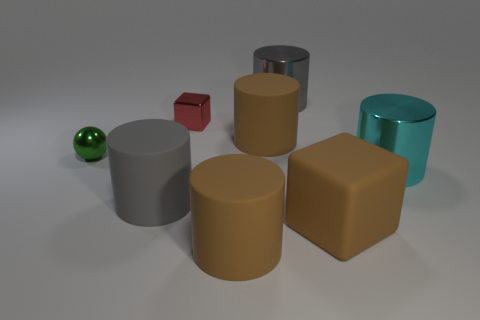What shape is the red thing that is the same material as the tiny green thing?
Your response must be concise. Cube. What number of rubber objects are big brown things or cyan objects?
Offer a very short reply. 3. There is a large shiny cylinder that is behind the big brown thing behind the large gray rubber cylinder; what number of large gray shiny cylinders are right of it?
Your response must be concise. 0. Do the matte thing to the left of the tiny red metallic object and the brown matte cylinder that is in front of the big block have the same size?
Ensure brevity in your answer.  Yes. What material is the other gray thing that is the same shape as the big gray shiny object?
Offer a terse response. Rubber. How many small things are either green spheres or gray things?
Offer a terse response. 1. What is the tiny green ball made of?
Provide a short and direct response. Metal. There is a cylinder that is to the right of the gray matte cylinder and in front of the big cyan shiny cylinder; what is its material?
Offer a very short reply. Rubber. There is a tiny metal cube; is it the same color as the matte thing behind the tiny green metallic thing?
Give a very brief answer. No. There is a brown block that is the same size as the cyan metallic cylinder; what is its material?
Your answer should be compact. Rubber. 